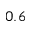Convert formula to latex. <formula><loc_0><loc_0><loc_500><loc_500>0 . 6</formula> 